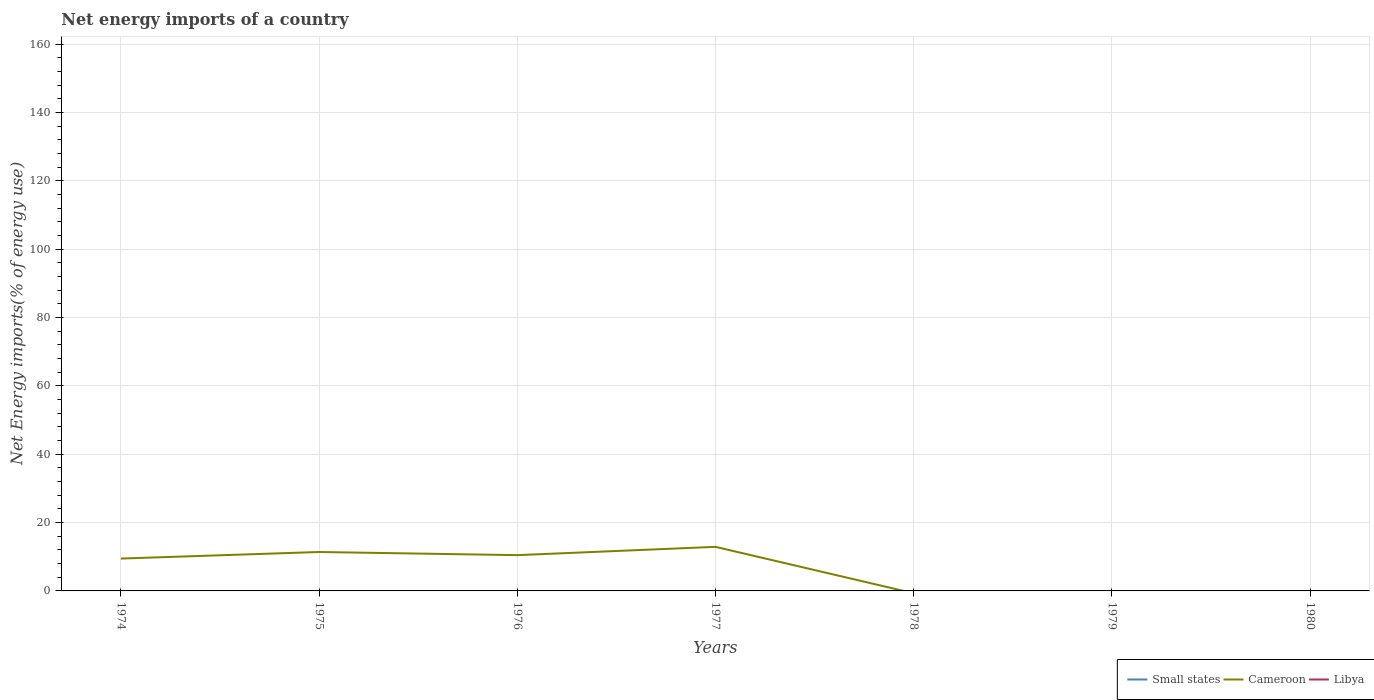Does the line corresponding to Small states intersect with the line corresponding to Libya?
Provide a succinct answer. No. Across all years, what is the maximum net energy imports in Libya?
Your answer should be very brief. 0. What is the total net energy imports in Cameroon in the graph?
Offer a terse response. -3.43. How many years are there in the graph?
Provide a succinct answer. 7. Does the graph contain grids?
Ensure brevity in your answer.  Yes. Where does the legend appear in the graph?
Offer a terse response. Bottom right. How many legend labels are there?
Your answer should be compact. 3. How are the legend labels stacked?
Make the answer very short. Horizontal. What is the title of the graph?
Offer a terse response. Net energy imports of a country. Does "Central Europe" appear as one of the legend labels in the graph?
Your response must be concise. No. What is the label or title of the X-axis?
Ensure brevity in your answer.  Years. What is the label or title of the Y-axis?
Keep it short and to the point. Net Energy imports(% of energy use). What is the Net Energy imports(% of energy use) in Cameroon in 1974?
Offer a terse response. 9.47. What is the Net Energy imports(% of energy use) of Small states in 1975?
Keep it short and to the point. 0. What is the Net Energy imports(% of energy use) in Cameroon in 1975?
Your answer should be compact. 11.39. What is the Net Energy imports(% of energy use) in Libya in 1975?
Offer a very short reply. 0. What is the Net Energy imports(% of energy use) of Cameroon in 1976?
Your answer should be compact. 10.47. What is the Net Energy imports(% of energy use) of Cameroon in 1977?
Provide a succinct answer. 12.9. What is the Net Energy imports(% of energy use) of Small states in 1978?
Offer a terse response. 0. What is the Net Energy imports(% of energy use) of Cameroon in 1978?
Give a very brief answer. 0. What is the Net Energy imports(% of energy use) of Libya in 1979?
Keep it short and to the point. 0. What is the Net Energy imports(% of energy use) of Small states in 1980?
Ensure brevity in your answer.  0. What is the Net Energy imports(% of energy use) in Cameroon in 1980?
Make the answer very short. 0. Across all years, what is the maximum Net Energy imports(% of energy use) of Cameroon?
Your answer should be very brief. 12.9. Across all years, what is the minimum Net Energy imports(% of energy use) in Cameroon?
Offer a terse response. 0. What is the total Net Energy imports(% of energy use) in Small states in the graph?
Provide a succinct answer. 0. What is the total Net Energy imports(% of energy use) of Cameroon in the graph?
Provide a short and direct response. 44.23. What is the total Net Energy imports(% of energy use) of Libya in the graph?
Ensure brevity in your answer.  0. What is the difference between the Net Energy imports(% of energy use) of Cameroon in 1974 and that in 1975?
Offer a very short reply. -1.92. What is the difference between the Net Energy imports(% of energy use) in Cameroon in 1974 and that in 1976?
Ensure brevity in your answer.  -1. What is the difference between the Net Energy imports(% of energy use) of Cameroon in 1974 and that in 1977?
Offer a terse response. -3.43. What is the difference between the Net Energy imports(% of energy use) of Cameroon in 1975 and that in 1976?
Give a very brief answer. 0.92. What is the difference between the Net Energy imports(% of energy use) of Cameroon in 1975 and that in 1977?
Give a very brief answer. -1.51. What is the difference between the Net Energy imports(% of energy use) of Cameroon in 1976 and that in 1977?
Provide a succinct answer. -2.43. What is the average Net Energy imports(% of energy use) in Cameroon per year?
Your answer should be compact. 6.32. What is the ratio of the Net Energy imports(% of energy use) in Cameroon in 1974 to that in 1975?
Your response must be concise. 0.83. What is the ratio of the Net Energy imports(% of energy use) in Cameroon in 1974 to that in 1976?
Offer a terse response. 0.9. What is the ratio of the Net Energy imports(% of energy use) in Cameroon in 1974 to that in 1977?
Offer a very short reply. 0.73. What is the ratio of the Net Energy imports(% of energy use) of Cameroon in 1975 to that in 1976?
Your answer should be very brief. 1.09. What is the ratio of the Net Energy imports(% of energy use) of Cameroon in 1975 to that in 1977?
Keep it short and to the point. 0.88. What is the ratio of the Net Energy imports(% of energy use) in Cameroon in 1976 to that in 1977?
Give a very brief answer. 0.81. What is the difference between the highest and the second highest Net Energy imports(% of energy use) in Cameroon?
Offer a terse response. 1.51. What is the difference between the highest and the lowest Net Energy imports(% of energy use) in Cameroon?
Offer a very short reply. 12.9. 